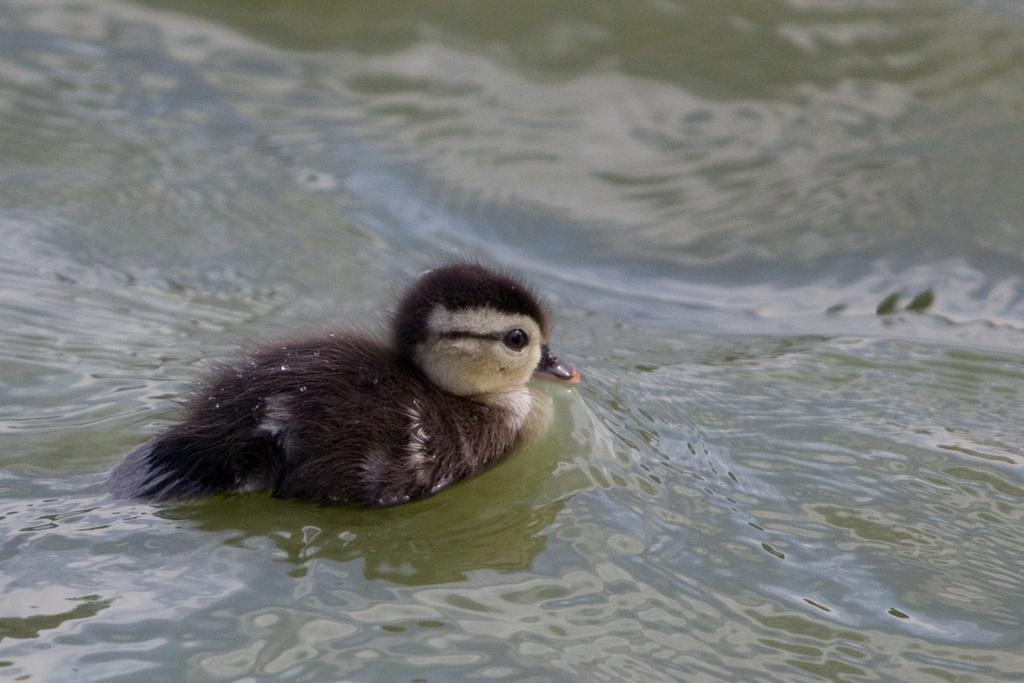Can you describe this image briefly? In this image we can see a bird in the water. 